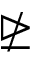Convert formula to latex. <formula><loc_0><loc_0><loc_500><loc_500>\ntrianglerighteq</formula> 